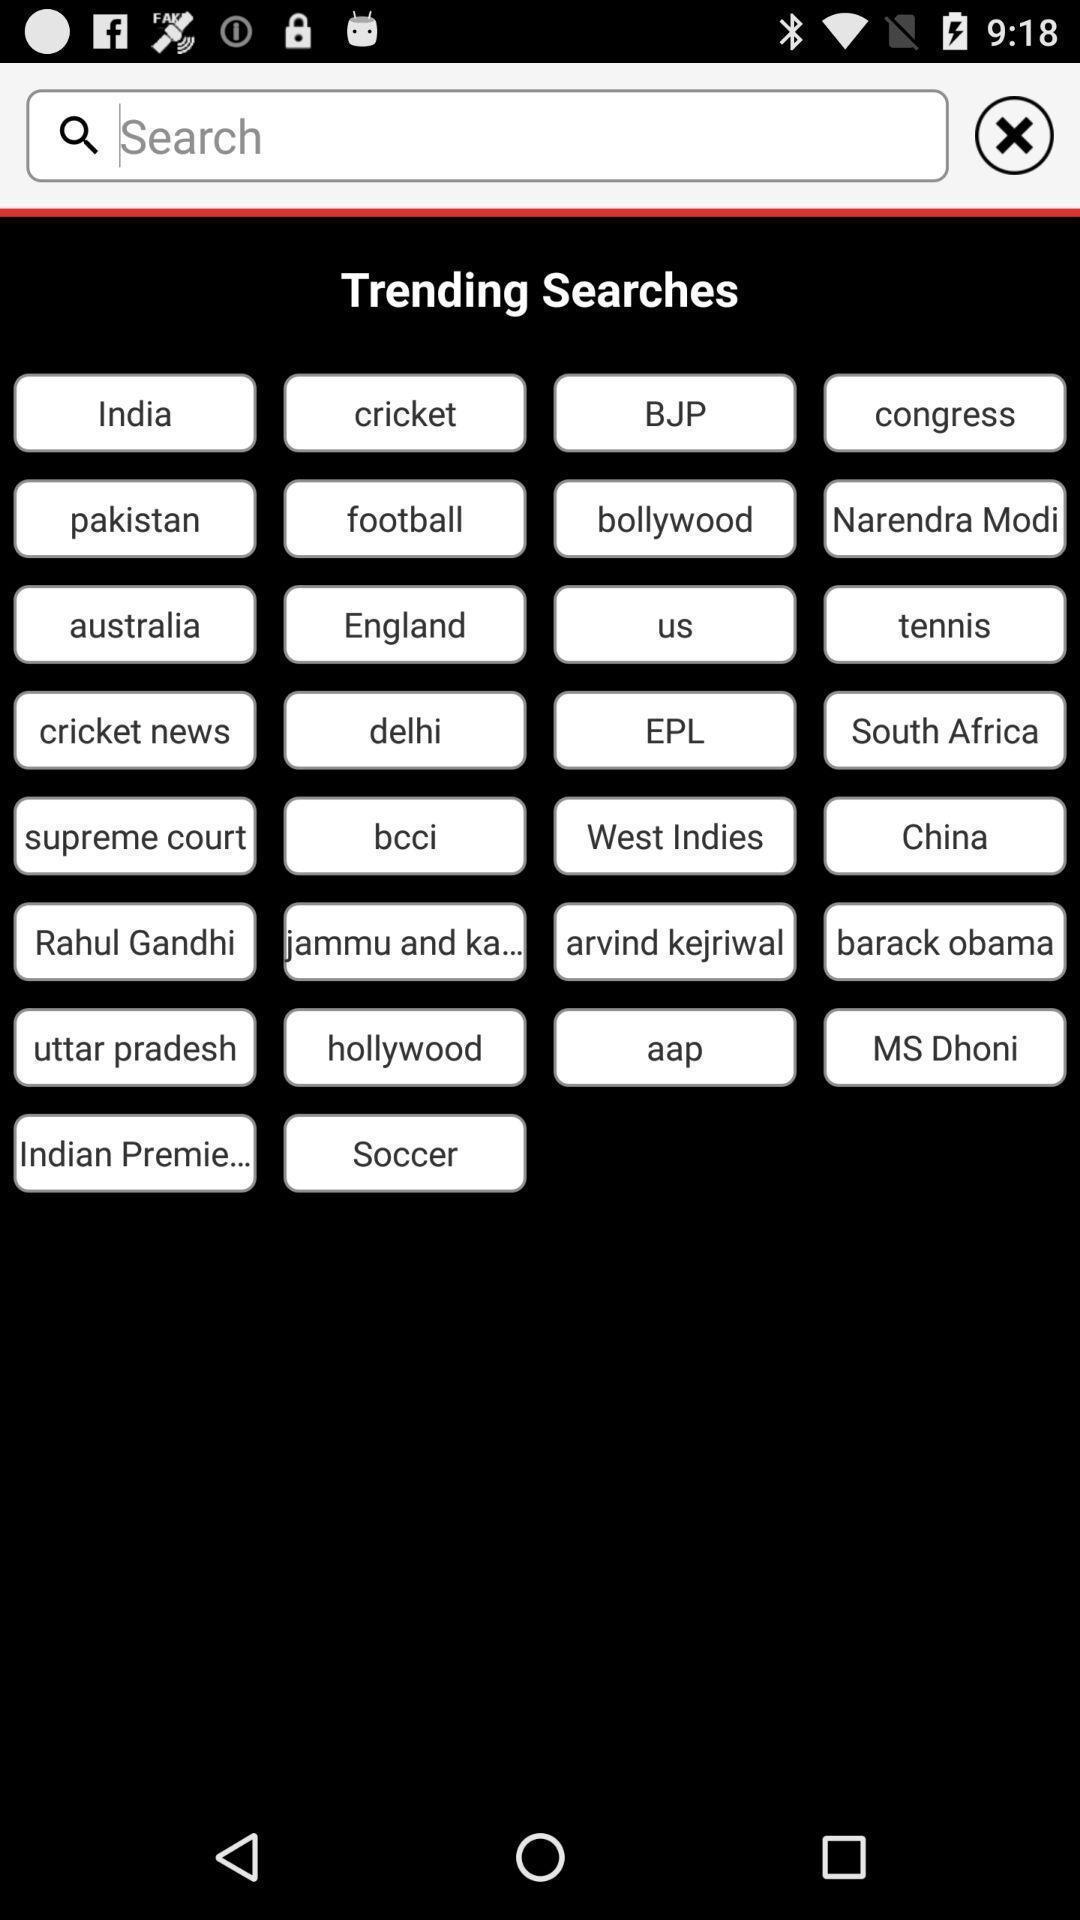Tell me what you see in this picture. Trending searches list showing in this page. 